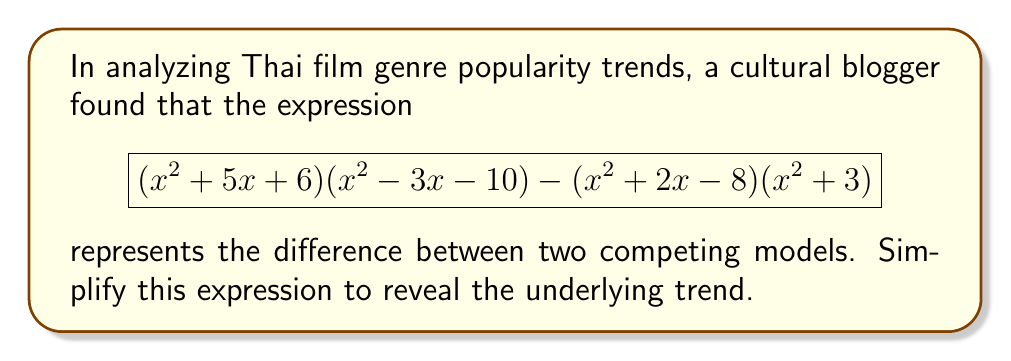Solve this math problem. Let's approach this step-by-step:

1) First, let's expand $(x^2 + 5x + 6)(x^2 - 3x - 10)$:
   $$(x^2 + 5x + 6)(x^2 - 3x - 10) = x^4 - 3x^3 - 10x^2 + 5x^3 - 15x^2 - 50x + 6x^2 - 18x - 60$$
   $$= x^4 + 2x^3 - 19x^2 - 68x - 60$$

2) Now, let's expand $(x^2 + 2x - 8)(x^2 + 3)$:
   $$(x^2 + 2x - 8)(x^2 + 3) = x^4 + 3x^2 + 2x^3 + 6x - 8x^2 - 24$$
   $$= x^4 + 2x^3 - 5x^2 + 6x - 24$$

3) Now, we subtract the second expansion from the first:
   $$(x^4 + 2x^3 - 19x^2 - 68x - 60) - (x^4 + 2x^3 - 5x^2 + 6x - 24)$$

4) Simplifying:
   $$x^4 + 2x^3 - 19x^2 - 68x - 60 - x^4 - 2x^3 + 5x^2 - 6x + 24$$
   $$= -14x^2 - 74x - 36$$

5) This can be factored:
   $$= -2(7x^2 + 37x + 18)$$
   $$= -2(7x + 2)(x + 9)$$

Thus, the simplified expression is $-2(7x + 2)(x + 9)$.
Answer: $-2(7x + 2)(x + 9)$ 